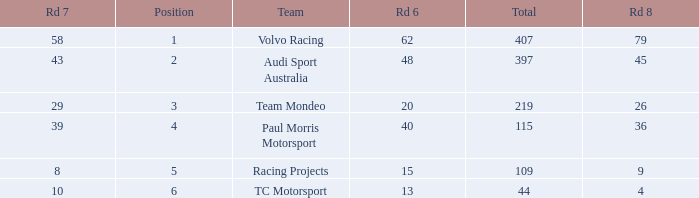In a position exceeding 1 for tc motorsport, what is the sum of rd 7 values when rd 6 is under 48 and rd 8 is less than 4? None. 